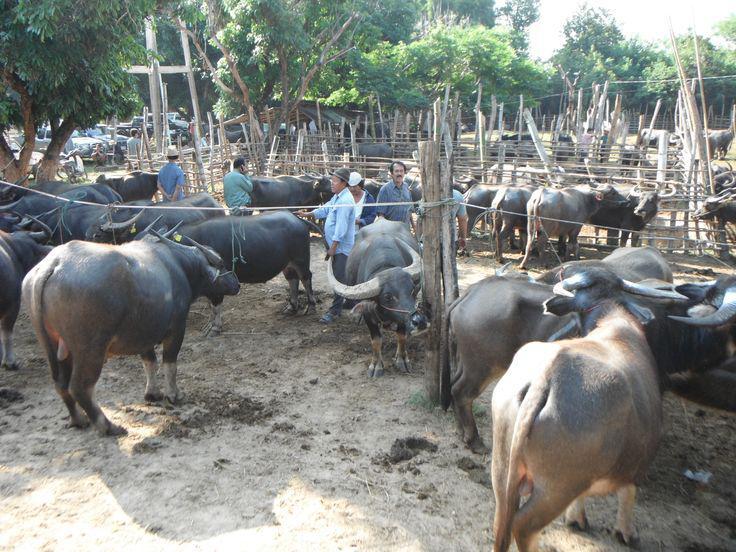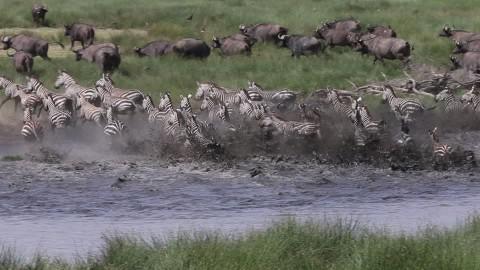The first image is the image on the left, the second image is the image on the right. Considering the images on both sides, is "All animals in the right image have horns." valid? Answer yes or no. No. The first image is the image on the left, the second image is the image on the right. Considering the images on both sides, is "At least one animal is in the water in the image on the right." valid? Answer yes or no. Yes. 